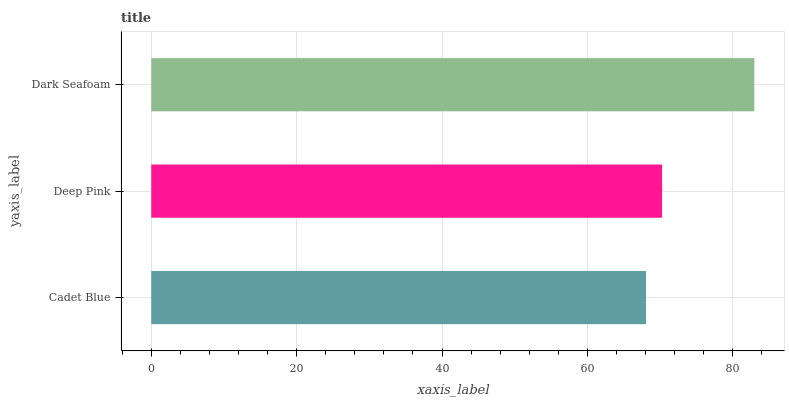Is Cadet Blue the minimum?
Answer yes or no. Yes. Is Dark Seafoam the maximum?
Answer yes or no. Yes. Is Deep Pink the minimum?
Answer yes or no. No. Is Deep Pink the maximum?
Answer yes or no. No. Is Deep Pink greater than Cadet Blue?
Answer yes or no. Yes. Is Cadet Blue less than Deep Pink?
Answer yes or no. Yes. Is Cadet Blue greater than Deep Pink?
Answer yes or no. No. Is Deep Pink less than Cadet Blue?
Answer yes or no. No. Is Deep Pink the high median?
Answer yes or no. Yes. Is Deep Pink the low median?
Answer yes or no. Yes. Is Dark Seafoam the high median?
Answer yes or no. No. Is Cadet Blue the low median?
Answer yes or no. No. 